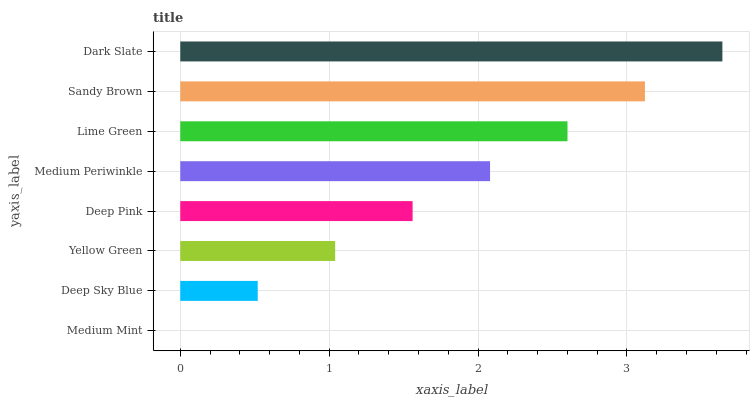Is Medium Mint the minimum?
Answer yes or no. Yes. Is Dark Slate the maximum?
Answer yes or no. Yes. Is Deep Sky Blue the minimum?
Answer yes or no. No. Is Deep Sky Blue the maximum?
Answer yes or no. No. Is Deep Sky Blue greater than Medium Mint?
Answer yes or no. Yes. Is Medium Mint less than Deep Sky Blue?
Answer yes or no. Yes. Is Medium Mint greater than Deep Sky Blue?
Answer yes or no. No. Is Deep Sky Blue less than Medium Mint?
Answer yes or no. No. Is Medium Periwinkle the high median?
Answer yes or no. Yes. Is Deep Pink the low median?
Answer yes or no. Yes. Is Dark Slate the high median?
Answer yes or no. No. Is Lime Green the low median?
Answer yes or no. No. 